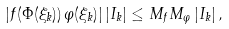Convert formula to latex. <formula><loc_0><loc_0><loc_500><loc_500>| f ( \Phi ( \xi _ { k } ) ) \, \varphi ( \xi _ { k } ) | \, | I _ { k } | \leq M _ { f } M _ { \varphi } \, | I _ { k } | \, ,</formula> 